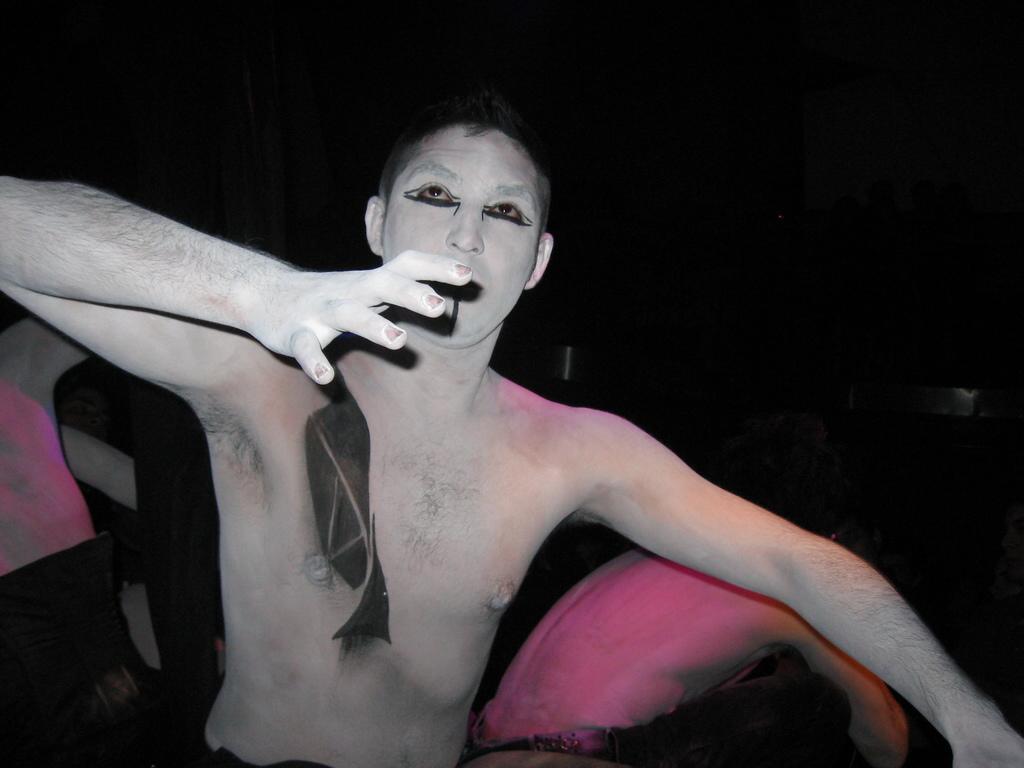How would you summarize this image in a sentence or two? This image is taken during night time. In this image we can see a person with painting on the body. In the background we can also see some persons. 